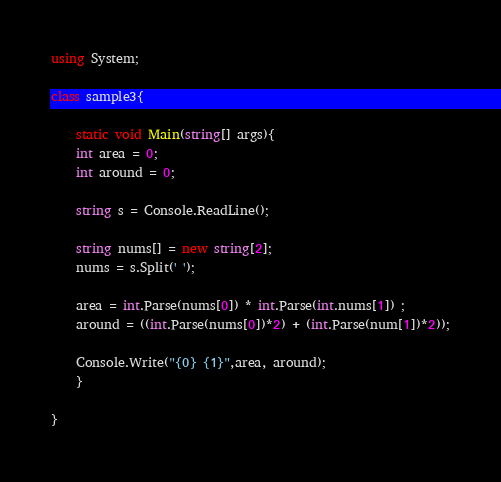Convert code to text. <code><loc_0><loc_0><loc_500><loc_500><_C#_>using System;

class sample3{
    
    static void Main(string[] args){
    int area = 0;
    int around = 0;
    
    string s = Console.ReadLine();
    
    string nums[] = new string[2]; 
    nums = s.Split(' ');
    
    area = int.Parse(nums[0]) * int.Parse(int.nums[1]) ;
    around = ((int.Parse(nums[0])*2) + (int.Parse(num[1])*2));
    
    Console.Write("{0} {1}",area, around);
    }

}
</code> 